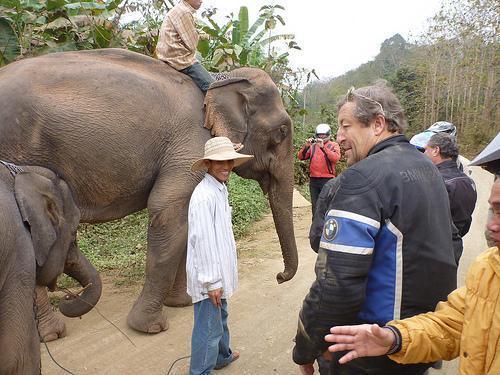How many elephant are there?
Give a very brief answer. 2. 